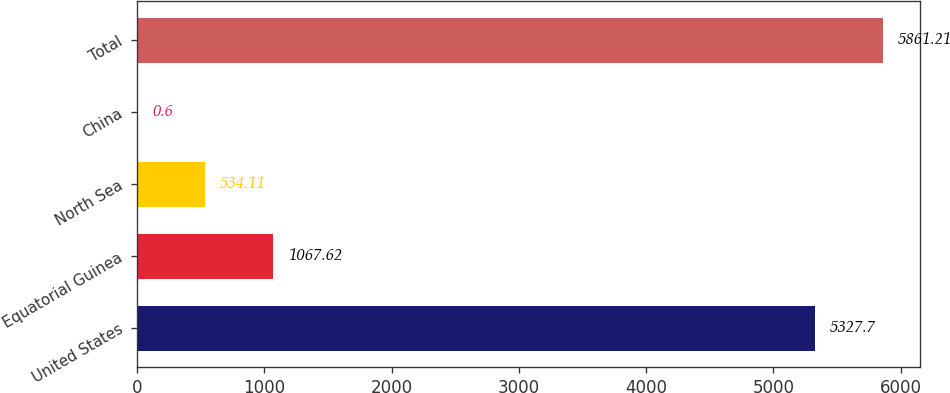Convert chart to OTSL. <chart><loc_0><loc_0><loc_500><loc_500><bar_chart><fcel>United States<fcel>Equatorial Guinea<fcel>North Sea<fcel>China<fcel>Total<nl><fcel>5327.7<fcel>1067.62<fcel>534.11<fcel>0.6<fcel>5861.21<nl></chart> 